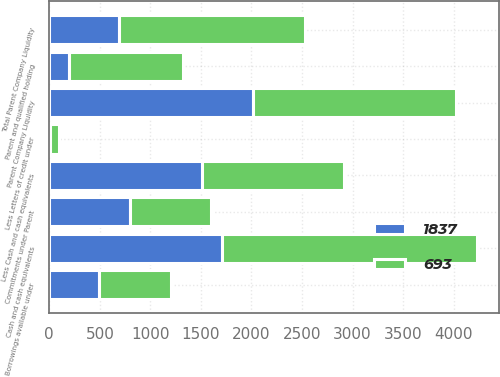Convert chart. <chart><loc_0><loc_0><loc_500><loc_500><stacked_bar_chart><ecel><fcel>Parent Company Liquidity<fcel>Cash and cash equivalents<fcel>Less Cash and cash equivalents<fcel>Parent and qualified holding<fcel>Commitments under Parent<fcel>Less Letters of credit under<fcel>Borrowings available under<fcel>Total Parent Company Liquidity<nl><fcel>1837<fcel>2011<fcel>1710<fcel>1510<fcel>200<fcel>800<fcel>12<fcel>493<fcel>693<nl><fcel>693<fcel>2010<fcel>2525<fcel>1403<fcel>1122<fcel>800<fcel>85<fcel>715<fcel>1837<nl></chart> 